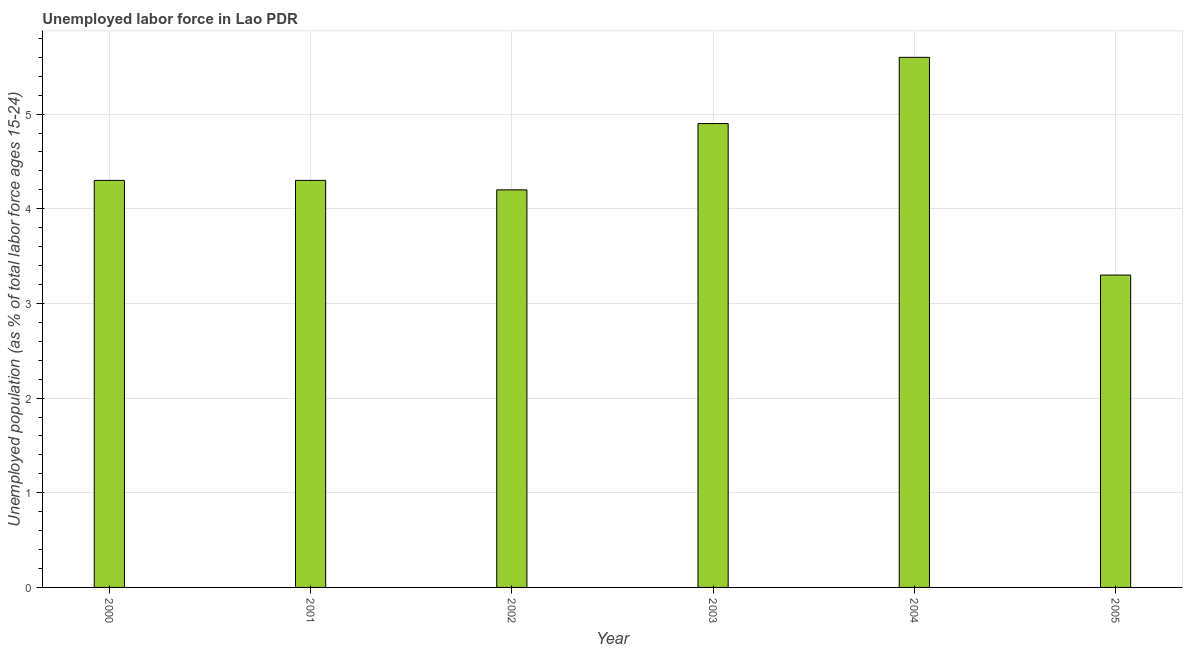Does the graph contain grids?
Offer a very short reply. Yes. What is the title of the graph?
Provide a short and direct response. Unemployed labor force in Lao PDR. What is the label or title of the Y-axis?
Your answer should be very brief. Unemployed population (as % of total labor force ages 15-24). What is the total unemployed youth population in 2003?
Make the answer very short. 4.9. Across all years, what is the maximum total unemployed youth population?
Offer a terse response. 5.6. Across all years, what is the minimum total unemployed youth population?
Make the answer very short. 3.3. What is the sum of the total unemployed youth population?
Make the answer very short. 26.6. What is the difference between the total unemployed youth population in 2001 and 2005?
Provide a succinct answer. 1. What is the average total unemployed youth population per year?
Provide a short and direct response. 4.43. What is the median total unemployed youth population?
Provide a short and direct response. 4.3. What is the ratio of the total unemployed youth population in 2001 to that in 2002?
Keep it short and to the point. 1.02. What is the difference between the highest and the second highest total unemployed youth population?
Keep it short and to the point. 0.7. What is the difference between the highest and the lowest total unemployed youth population?
Your response must be concise. 2.3. In how many years, is the total unemployed youth population greater than the average total unemployed youth population taken over all years?
Offer a terse response. 2. How many bars are there?
Your answer should be very brief. 6. How many years are there in the graph?
Ensure brevity in your answer.  6. What is the difference between two consecutive major ticks on the Y-axis?
Your response must be concise. 1. Are the values on the major ticks of Y-axis written in scientific E-notation?
Your response must be concise. No. What is the Unemployed population (as % of total labor force ages 15-24) of 2000?
Make the answer very short. 4.3. What is the Unemployed population (as % of total labor force ages 15-24) in 2001?
Make the answer very short. 4.3. What is the Unemployed population (as % of total labor force ages 15-24) in 2002?
Make the answer very short. 4.2. What is the Unemployed population (as % of total labor force ages 15-24) of 2003?
Ensure brevity in your answer.  4.9. What is the Unemployed population (as % of total labor force ages 15-24) of 2004?
Offer a terse response. 5.6. What is the Unemployed population (as % of total labor force ages 15-24) in 2005?
Your answer should be very brief. 3.3. What is the difference between the Unemployed population (as % of total labor force ages 15-24) in 2000 and 2001?
Keep it short and to the point. 0. What is the difference between the Unemployed population (as % of total labor force ages 15-24) in 2000 and 2002?
Ensure brevity in your answer.  0.1. What is the difference between the Unemployed population (as % of total labor force ages 15-24) in 2000 and 2003?
Keep it short and to the point. -0.6. What is the difference between the Unemployed population (as % of total labor force ages 15-24) in 2000 and 2004?
Your answer should be very brief. -1.3. What is the difference between the Unemployed population (as % of total labor force ages 15-24) in 2000 and 2005?
Make the answer very short. 1. What is the difference between the Unemployed population (as % of total labor force ages 15-24) in 2001 and 2004?
Provide a succinct answer. -1.3. What is the difference between the Unemployed population (as % of total labor force ages 15-24) in 2002 and 2003?
Offer a terse response. -0.7. What is the difference between the Unemployed population (as % of total labor force ages 15-24) in 2002 and 2004?
Give a very brief answer. -1.4. What is the difference between the Unemployed population (as % of total labor force ages 15-24) in 2003 and 2004?
Provide a succinct answer. -0.7. What is the difference between the Unemployed population (as % of total labor force ages 15-24) in 2003 and 2005?
Offer a terse response. 1.6. What is the difference between the Unemployed population (as % of total labor force ages 15-24) in 2004 and 2005?
Make the answer very short. 2.3. What is the ratio of the Unemployed population (as % of total labor force ages 15-24) in 2000 to that in 2003?
Offer a terse response. 0.88. What is the ratio of the Unemployed population (as % of total labor force ages 15-24) in 2000 to that in 2004?
Provide a succinct answer. 0.77. What is the ratio of the Unemployed population (as % of total labor force ages 15-24) in 2000 to that in 2005?
Give a very brief answer. 1.3. What is the ratio of the Unemployed population (as % of total labor force ages 15-24) in 2001 to that in 2003?
Offer a terse response. 0.88. What is the ratio of the Unemployed population (as % of total labor force ages 15-24) in 2001 to that in 2004?
Offer a very short reply. 0.77. What is the ratio of the Unemployed population (as % of total labor force ages 15-24) in 2001 to that in 2005?
Ensure brevity in your answer.  1.3. What is the ratio of the Unemployed population (as % of total labor force ages 15-24) in 2002 to that in 2003?
Provide a succinct answer. 0.86. What is the ratio of the Unemployed population (as % of total labor force ages 15-24) in 2002 to that in 2004?
Make the answer very short. 0.75. What is the ratio of the Unemployed population (as % of total labor force ages 15-24) in 2002 to that in 2005?
Offer a terse response. 1.27. What is the ratio of the Unemployed population (as % of total labor force ages 15-24) in 2003 to that in 2004?
Keep it short and to the point. 0.88. What is the ratio of the Unemployed population (as % of total labor force ages 15-24) in 2003 to that in 2005?
Make the answer very short. 1.49. What is the ratio of the Unemployed population (as % of total labor force ages 15-24) in 2004 to that in 2005?
Provide a short and direct response. 1.7. 